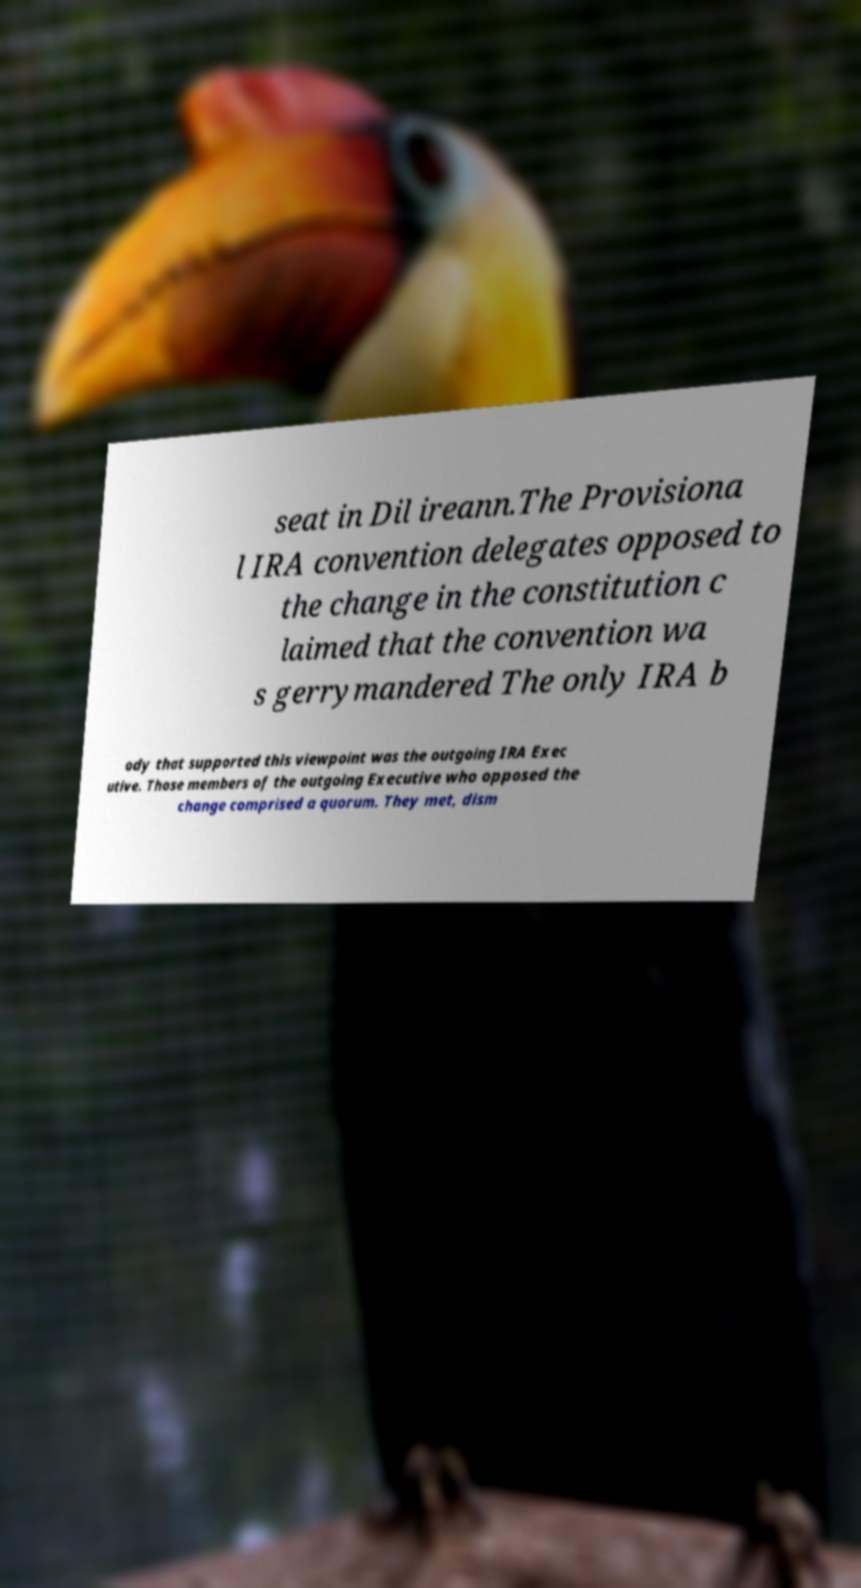I need the written content from this picture converted into text. Can you do that? seat in Dil ireann.The Provisiona l IRA convention delegates opposed to the change in the constitution c laimed that the convention wa s gerrymandered The only IRA b ody that supported this viewpoint was the outgoing IRA Exec utive. Those members of the outgoing Executive who opposed the change comprised a quorum. They met, dism 